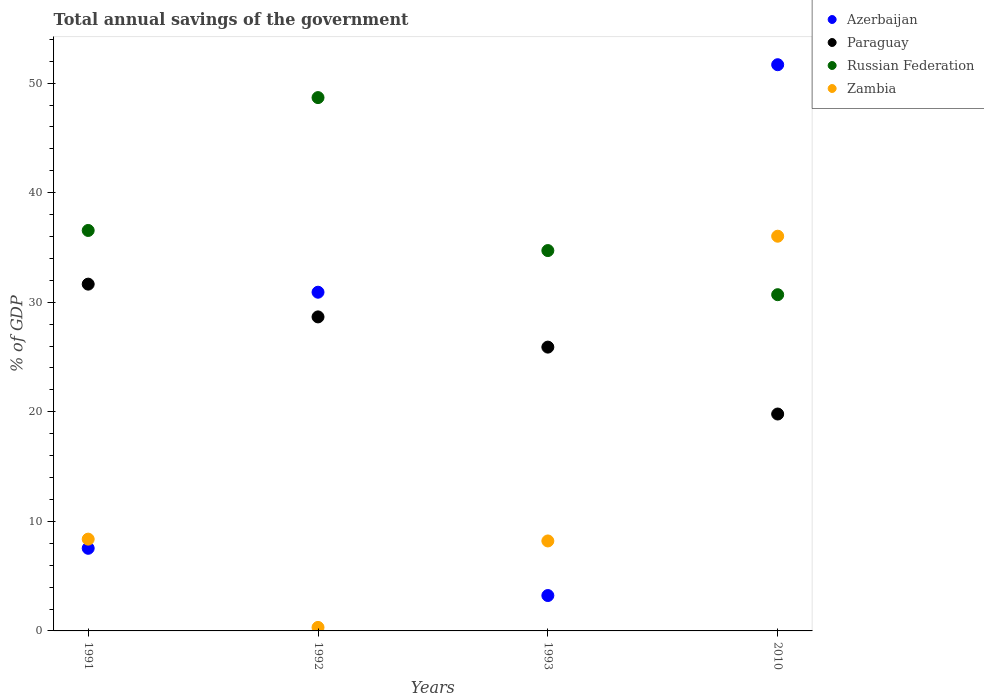How many different coloured dotlines are there?
Keep it short and to the point. 4. Is the number of dotlines equal to the number of legend labels?
Keep it short and to the point. Yes. What is the total annual savings of the government in Azerbaijan in 1991?
Ensure brevity in your answer.  7.54. Across all years, what is the maximum total annual savings of the government in Zambia?
Give a very brief answer. 36.03. Across all years, what is the minimum total annual savings of the government in Paraguay?
Keep it short and to the point. 19.8. What is the total total annual savings of the government in Azerbaijan in the graph?
Your response must be concise. 93.37. What is the difference between the total annual savings of the government in Paraguay in 1992 and that in 2010?
Keep it short and to the point. 8.86. What is the difference between the total annual savings of the government in Paraguay in 1993 and the total annual savings of the government in Russian Federation in 1992?
Keep it short and to the point. -22.78. What is the average total annual savings of the government in Zambia per year?
Give a very brief answer. 13.23. In the year 1993, what is the difference between the total annual savings of the government in Zambia and total annual savings of the government in Azerbaijan?
Provide a succinct answer. 4.98. In how many years, is the total annual savings of the government in Paraguay greater than 12 %?
Give a very brief answer. 4. What is the ratio of the total annual savings of the government in Paraguay in 1991 to that in 1992?
Offer a terse response. 1.1. What is the difference between the highest and the second highest total annual savings of the government in Azerbaijan?
Keep it short and to the point. 20.77. What is the difference between the highest and the lowest total annual savings of the government in Zambia?
Your answer should be compact. 35.71. Is it the case that in every year, the sum of the total annual savings of the government in Zambia and total annual savings of the government in Russian Federation  is greater than the sum of total annual savings of the government in Azerbaijan and total annual savings of the government in Paraguay?
Offer a very short reply. No. Does the total annual savings of the government in Azerbaijan monotonically increase over the years?
Keep it short and to the point. No. Is the total annual savings of the government in Zambia strictly less than the total annual savings of the government in Azerbaijan over the years?
Your answer should be very brief. No. How many dotlines are there?
Your answer should be very brief. 4. What is the difference between two consecutive major ticks on the Y-axis?
Your answer should be compact. 10. Are the values on the major ticks of Y-axis written in scientific E-notation?
Offer a very short reply. No. Does the graph contain any zero values?
Make the answer very short. No. Does the graph contain grids?
Offer a very short reply. No. Where does the legend appear in the graph?
Give a very brief answer. Top right. What is the title of the graph?
Your answer should be very brief. Total annual savings of the government. Does "Tuvalu" appear as one of the legend labels in the graph?
Keep it short and to the point. No. What is the label or title of the Y-axis?
Make the answer very short. % of GDP. What is the % of GDP of Azerbaijan in 1991?
Your response must be concise. 7.54. What is the % of GDP of Paraguay in 1991?
Your answer should be compact. 31.65. What is the % of GDP of Russian Federation in 1991?
Your answer should be very brief. 36.55. What is the % of GDP in Zambia in 1991?
Keep it short and to the point. 8.38. What is the % of GDP of Azerbaijan in 1992?
Provide a short and direct response. 30.92. What is the % of GDP in Paraguay in 1992?
Your response must be concise. 28.66. What is the % of GDP of Russian Federation in 1992?
Keep it short and to the point. 48.68. What is the % of GDP of Zambia in 1992?
Ensure brevity in your answer.  0.32. What is the % of GDP in Azerbaijan in 1993?
Your answer should be compact. 3.23. What is the % of GDP of Paraguay in 1993?
Make the answer very short. 25.91. What is the % of GDP in Russian Federation in 1993?
Provide a short and direct response. 34.72. What is the % of GDP of Zambia in 1993?
Ensure brevity in your answer.  8.21. What is the % of GDP of Azerbaijan in 2010?
Your answer should be very brief. 51.68. What is the % of GDP of Paraguay in 2010?
Ensure brevity in your answer.  19.8. What is the % of GDP in Russian Federation in 2010?
Give a very brief answer. 30.69. What is the % of GDP of Zambia in 2010?
Your answer should be compact. 36.03. Across all years, what is the maximum % of GDP in Azerbaijan?
Your answer should be compact. 51.68. Across all years, what is the maximum % of GDP of Paraguay?
Your answer should be very brief. 31.65. Across all years, what is the maximum % of GDP of Russian Federation?
Your response must be concise. 48.68. Across all years, what is the maximum % of GDP of Zambia?
Offer a terse response. 36.03. Across all years, what is the minimum % of GDP of Azerbaijan?
Your answer should be compact. 3.23. Across all years, what is the minimum % of GDP of Paraguay?
Offer a very short reply. 19.8. Across all years, what is the minimum % of GDP in Russian Federation?
Keep it short and to the point. 30.69. Across all years, what is the minimum % of GDP of Zambia?
Make the answer very short. 0.32. What is the total % of GDP in Azerbaijan in the graph?
Your response must be concise. 93.37. What is the total % of GDP in Paraguay in the graph?
Provide a succinct answer. 106.02. What is the total % of GDP in Russian Federation in the graph?
Provide a short and direct response. 150.64. What is the total % of GDP of Zambia in the graph?
Provide a short and direct response. 52.94. What is the difference between the % of GDP of Azerbaijan in 1991 and that in 1992?
Your answer should be compact. -23.38. What is the difference between the % of GDP of Paraguay in 1991 and that in 1992?
Your response must be concise. 2.99. What is the difference between the % of GDP in Russian Federation in 1991 and that in 1992?
Your answer should be compact. -12.13. What is the difference between the % of GDP in Zambia in 1991 and that in 1992?
Provide a succinct answer. 8.06. What is the difference between the % of GDP of Azerbaijan in 1991 and that in 1993?
Offer a very short reply. 4.31. What is the difference between the % of GDP in Paraguay in 1991 and that in 1993?
Keep it short and to the point. 5.75. What is the difference between the % of GDP in Russian Federation in 1991 and that in 1993?
Provide a succinct answer. 1.84. What is the difference between the % of GDP in Zambia in 1991 and that in 1993?
Give a very brief answer. 0.17. What is the difference between the % of GDP of Azerbaijan in 1991 and that in 2010?
Give a very brief answer. -44.14. What is the difference between the % of GDP of Paraguay in 1991 and that in 2010?
Keep it short and to the point. 11.86. What is the difference between the % of GDP in Russian Federation in 1991 and that in 2010?
Ensure brevity in your answer.  5.86. What is the difference between the % of GDP of Zambia in 1991 and that in 2010?
Your answer should be very brief. -27.65. What is the difference between the % of GDP of Azerbaijan in 1992 and that in 1993?
Your answer should be very brief. 27.69. What is the difference between the % of GDP in Paraguay in 1992 and that in 1993?
Offer a terse response. 2.76. What is the difference between the % of GDP of Russian Federation in 1992 and that in 1993?
Offer a very short reply. 13.96. What is the difference between the % of GDP of Zambia in 1992 and that in 1993?
Make the answer very short. -7.89. What is the difference between the % of GDP of Azerbaijan in 1992 and that in 2010?
Your answer should be compact. -20.77. What is the difference between the % of GDP in Paraguay in 1992 and that in 2010?
Keep it short and to the point. 8.86. What is the difference between the % of GDP of Russian Federation in 1992 and that in 2010?
Provide a succinct answer. 17.99. What is the difference between the % of GDP of Zambia in 1992 and that in 2010?
Ensure brevity in your answer.  -35.71. What is the difference between the % of GDP of Azerbaijan in 1993 and that in 2010?
Provide a short and direct response. -48.45. What is the difference between the % of GDP of Paraguay in 1993 and that in 2010?
Your response must be concise. 6.11. What is the difference between the % of GDP of Russian Federation in 1993 and that in 2010?
Ensure brevity in your answer.  4.03. What is the difference between the % of GDP of Zambia in 1993 and that in 2010?
Offer a terse response. -27.82. What is the difference between the % of GDP of Azerbaijan in 1991 and the % of GDP of Paraguay in 1992?
Offer a terse response. -21.12. What is the difference between the % of GDP of Azerbaijan in 1991 and the % of GDP of Russian Federation in 1992?
Ensure brevity in your answer.  -41.14. What is the difference between the % of GDP of Azerbaijan in 1991 and the % of GDP of Zambia in 1992?
Keep it short and to the point. 7.22. What is the difference between the % of GDP in Paraguay in 1991 and the % of GDP in Russian Federation in 1992?
Provide a short and direct response. -17.03. What is the difference between the % of GDP of Paraguay in 1991 and the % of GDP of Zambia in 1992?
Your response must be concise. 31.33. What is the difference between the % of GDP in Russian Federation in 1991 and the % of GDP in Zambia in 1992?
Your answer should be very brief. 36.23. What is the difference between the % of GDP of Azerbaijan in 1991 and the % of GDP of Paraguay in 1993?
Provide a succinct answer. -18.36. What is the difference between the % of GDP of Azerbaijan in 1991 and the % of GDP of Russian Federation in 1993?
Offer a terse response. -27.18. What is the difference between the % of GDP of Azerbaijan in 1991 and the % of GDP of Zambia in 1993?
Your answer should be very brief. -0.67. What is the difference between the % of GDP in Paraguay in 1991 and the % of GDP in Russian Federation in 1993?
Offer a very short reply. -3.06. What is the difference between the % of GDP in Paraguay in 1991 and the % of GDP in Zambia in 1993?
Make the answer very short. 23.44. What is the difference between the % of GDP in Russian Federation in 1991 and the % of GDP in Zambia in 1993?
Make the answer very short. 28.34. What is the difference between the % of GDP of Azerbaijan in 1991 and the % of GDP of Paraguay in 2010?
Ensure brevity in your answer.  -12.26. What is the difference between the % of GDP in Azerbaijan in 1991 and the % of GDP in Russian Federation in 2010?
Your answer should be compact. -23.15. What is the difference between the % of GDP in Azerbaijan in 1991 and the % of GDP in Zambia in 2010?
Keep it short and to the point. -28.49. What is the difference between the % of GDP in Paraguay in 1991 and the % of GDP in Russian Federation in 2010?
Give a very brief answer. 0.96. What is the difference between the % of GDP in Paraguay in 1991 and the % of GDP in Zambia in 2010?
Your answer should be compact. -4.38. What is the difference between the % of GDP of Russian Federation in 1991 and the % of GDP of Zambia in 2010?
Your answer should be very brief. 0.52. What is the difference between the % of GDP of Azerbaijan in 1992 and the % of GDP of Paraguay in 1993?
Your answer should be very brief. 5.01. What is the difference between the % of GDP of Azerbaijan in 1992 and the % of GDP of Russian Federation in 1993?
Keep it short and to the point. -3.8. What is the difference between the % of GDP of Azerbaijan in 1992 and the % of GDP of Zambia in 1993?
Ensure brevity in your answer.  22.7. What is the difference between the % of GDP of Paraguay in 1992 and the % of GDP of Russian Federation in 1993?
Your answer should be very brief. -6.05. What is the difference between the % of GDP of Paraguay in 1992 and the % of GDP of Zambia in 1993?
Keep it short and to the point. 20.45. What is the difference between the % of GDP in Russian Federation in 1992 and the % of GDP in Zambia in 1993?
Ensure brevity in your answer.  40.47. What is the difference between the % of GDP in Azerbaijan in 1992 and the % of GDP in Paraguay in 2010?
Offer a very short reply. 11.12. What is the difference between the % of GDP in Azerbaijan in 1992 and the % of GDP in Russian Federation in 2010?
Your response must be concise. 0.23. What is the difference between the % of GDP of Azerbaijan in 1992 and the % of GDP of Zambia in 2010?
Keep it short and to the point. -5.11. What is the difference between the % of GDP in Paraguay in 1992 and the % of GDP in Russian Federation in 2010?
Keep it short and to the point. -2.03. What is the difference between the % of GDP of Paraguay in 1992 and the % of GDP of Zambia in 2010?
Your answer should be very brief. -7.37. What is the difference between the % of GDP in Russian Federation in 1992 and the % of GDP in Zambia in 2010?
Give a very brief answer. 12.65. What is the difference between the % of GDP of Azerbaijan in 1993 and the % of GDP of Paraguay in 2010?
Your response must be concise. -16.57. What is the difference between the % of GDP of Azerbaijan in 1993 and the % of GDP of Russian Federation in 2010?
Ensure brevity in your answer.  -27.46. What is the difference between the % of GDP in Azerbaijan in 1993 and the % of GDP in Zambia in 2010?
Offer a very short reply. -32.8. What is the difference between the % of GDP of Paraguay in 1993 and the % of GDP of Russian Federation in 2010?
Your answer should be compact. -4.79. What is the difference between the % of GDP of Paraguay in 1993 and the % of GDP of Zambia in 2010?
Offer a very short reply. -10.12. What is the difference between the % of GDP in Russian Federation in 1993 and the % of GDP in Zambia in 2010?
Offer a terse response. -1.31. What is the average % of GDP in Azerbaijan per year?
Offer a very short reply. 23.34. What is the average % of GDP of Paraguay per year?
Your response must be concise. 26.51. What is the average % of GDP in Russian Federation per year?
Make the answer very short. 37.66. What is the average % of GDP in Zambia per year?
Provide a short and direct response. 13.23. In the year 1991, what is the difference between the % of GDP of Azerbaijan and % of GDP of Paraguay?
Provide a succinct answer. -24.11. In the year 1991, what is the difference between the % of GDP of Azerbaijan and % of GDP of Russian Federation?
Offer a very short reply. -29.01. In the year 1991, what is the difference between the % of GDP in Azerbaijan and % of GDP in Zambia?
Make the answer very short. -0.84. In the year 1991, what is the difference between the % of GDP of Paraguay and % of GDP of Russian Federation?
Your answer should be compact. -4.9. In the year 1991, what is the difference between the % of GDP of Paraguay and % of GDP of Zambia?
Offer a terse response. 23.28. In the year 1991, what is the difference between the % of GDP in Russian Federation and % of GDP in Zambia?
Provide a succinct answer. 28.18. In the year 1992, what is the difference between the % of GDP in Azerbaijan and % of GDP in Paraguay?
Your response must be concise. 2.25. In the year 1992, what is the difference between the % of GDP of Azerbaijan and % of GDP of Russian Federation?
Make the answer very short. -17.76. In the year 1992, what is the difference between the % of GDP of Azerbaijan and % of GDP of Zambia?
Your answer should be very brief. 30.6. In the year 1992, what is the difference between the % of GDP in Paraguay and % of GDP in Russian Federation?
Provide a short and direct response. -20.02. In the year 1992, what is the difference between the % of GDP in Paraguay and % of GDP in Zambia?
Your response must be concise. 28.34. In the year 1992, what is the difference between the % of GDP in Russian Federation and % of GDP in Zambia?
Offer a very short reply. 48.36. In the year 1993, what is the difference between the % of GDP of Azerbaijan and % of GDP of Paraguay?
Keep it short and to the point. -22.68. In the year 1993, what is the difference between the % of GDP in Azerbaijan and % of GDP in Russian Federation?
Your answer should be very brief. -31.49. In the year 1993, what is the difference between the % of GDP in Azerbaijan and % of GDP in Zambia?
Your response must be concise. -4.98. In the year 1993, what is the difference between the % of GDP in Paraguay and % of GDP in Russian Federation?
Ensure brevity in your answer.  -8.81. In the year 1993, what is the difference between the % of GDP of Paraguay and % of GDP of Zambia?
Give a very brief answer. 17.69. In the year 1993, what is the difference between the % of GDP in Russian Federation and % of GDP in Zambia?
Offer a very short reply. 26.51. In the year 2010, what is the difference between the % of GDP in Azerbaijan and % of GDP in Paraguay?
Make the answer very short. 31.88. In the year 2010, what is the difference between the % of GDP of Azerbaijan and % of GDP of Russian Federation?
Offer a terse response. 20.99. In the year 2010, what is the difference between the % of GDP of Azerbaijan and % of GDP of Zambia?
Provide a succinct answer. 15.65. In the year 2010, what is the difference between the % of GDP in Paraguay and % of GDP in Russian Federation?
Provide a succinct answer. -10.89. In the year 2010, what is the difference between the % of GDP in Paraguay and % of GDP in Zambia?
Make the answer very short. -16.23. In the year 2010, what is the difference between the % of GDP of Russian Federation and % of GDP of Zambia?
Provide a short and direct response. -5.34. What is the ratio of the % of GDP in Azerbaijan in 1991 to that in 1992?
Ensure brevity in your answer.  0.24. What is the ratio of the % of GDP of Paraguay in 1991 to that in 1992?
Offer a terse response. 1.1. What is the ratio of the % of GDP in Russian Federation in 1991 to that in 1992?
Provide a succinct answer. 0.75. What is the ratio of the % of GDP in Zambia in 1991 to that in 1992?
Make the answer very short. 26.13. What is the ratio of the % of GDP in Azerbaijan in 1991 to that in 1993?
Offer a terse response. 2.33. What is the ratio of the % of GDP in Paraguay in 1991 to that in 1993?
Your answer should be compact. 1.22. What is the ratio of the % of GDP in Russian Federation in 1991 to that in 1993?
Keep it short and to the point. 1.05. What is the ratio of the % of GDP in Zambia in 1991 to that in 1993?
Offer a very short reply. 1.02. What is the ratio of the % of GDP of Azerbaijan in 1991 to that in 2010?
Your answer should be compact. 0.15. What is the ratio of the % of GDP of Paraguay in 1991 to that in 2010?
Keep it short and to the point. 1.6. What is the ratio of the % of GDP of Russian Federation in 1991 to that in 2010?
Keep it short and to the point. 1.19. What is the ratio of the % of GDP in Zambia in 1991 to that in 2010?
Offer a terse response. 0.23. What is the ratio of the % of GDP in Azerbaijan in 1992 to that in 1993?
Offer a very short reply. 9.57. What is the ratio of the % of GDP in Paraguay in 1992 to that in 1993?
Provide a succinct answer. 1.11. What is the ratio of the % of GDP in Russian Federation in 1992 to that in 1993?
Keep it short and to the point. 1.4. What is the ratio of the % of GDP in Zambia in 1992 to that in 1993?
Provide a succinct answer. 0.04. What is the ratio of the % of GDP of Azerbaijan in 1992 to that in 2010?
Your answer should be very brief. 0.6. What is the ratio of the % of GDP of Paraguay in 1992 to that in 2010?
Your response must be concise. 1.45. What is the ratio of the % of GDP of Russian Federation in 1992 to that in 2010?
Your answer should be compact. 1.59. What is the ratio of the % of GDP in Zambia in 1992 to that in 2010?
Your answer should be compact. 0.01. What is the ratio of the % of GDP of Azerbaijan in 1993 to that in 2010?
Provide a succinct answer. 0.06. What is the ratio of the % of GDP in Paraguay in 1993 to that in 2010?
Offer a very short reply. 1.31. What is the ratio of the % of GDP of Russian Federation in 1993 to that in 2010?
Your response must be concise. 1.13. What is the ratio of the % of GDP of Zambia in 1993 to that in 2010?
Offer a very short reply. 0.23. What is the difference between the highest and the second highest % of GDP in Azerbaijan?
Make the answer very short. 20.77. What is the difference between the highest and the second highest % of GDP of Paraguay?
Offer a very short reply. 2.99. What is the difference between the highest and the second highest % of GDP in Russian Federation?
Offer a terse response. 12.13. What is the difference between the highest and the second highest % of GDP of Zambia?
Your answer should be compact. 27.65. What is the difference between the highest and the lowest % of GDP in Azerbaijan?
Provide a succinct answer. 48.45. What is the difference between the highest and the lowest % of GDP in Paraguay?
Your answer should be very brief. 11.86. What is the difference between the highest and the lowest % of GDP of Russian Federation?
Your answer should be very brief. 17.99. What is the difference between the highest and the lowest % of GDP of Zambia?
Your answer should be compact. 35.71. 